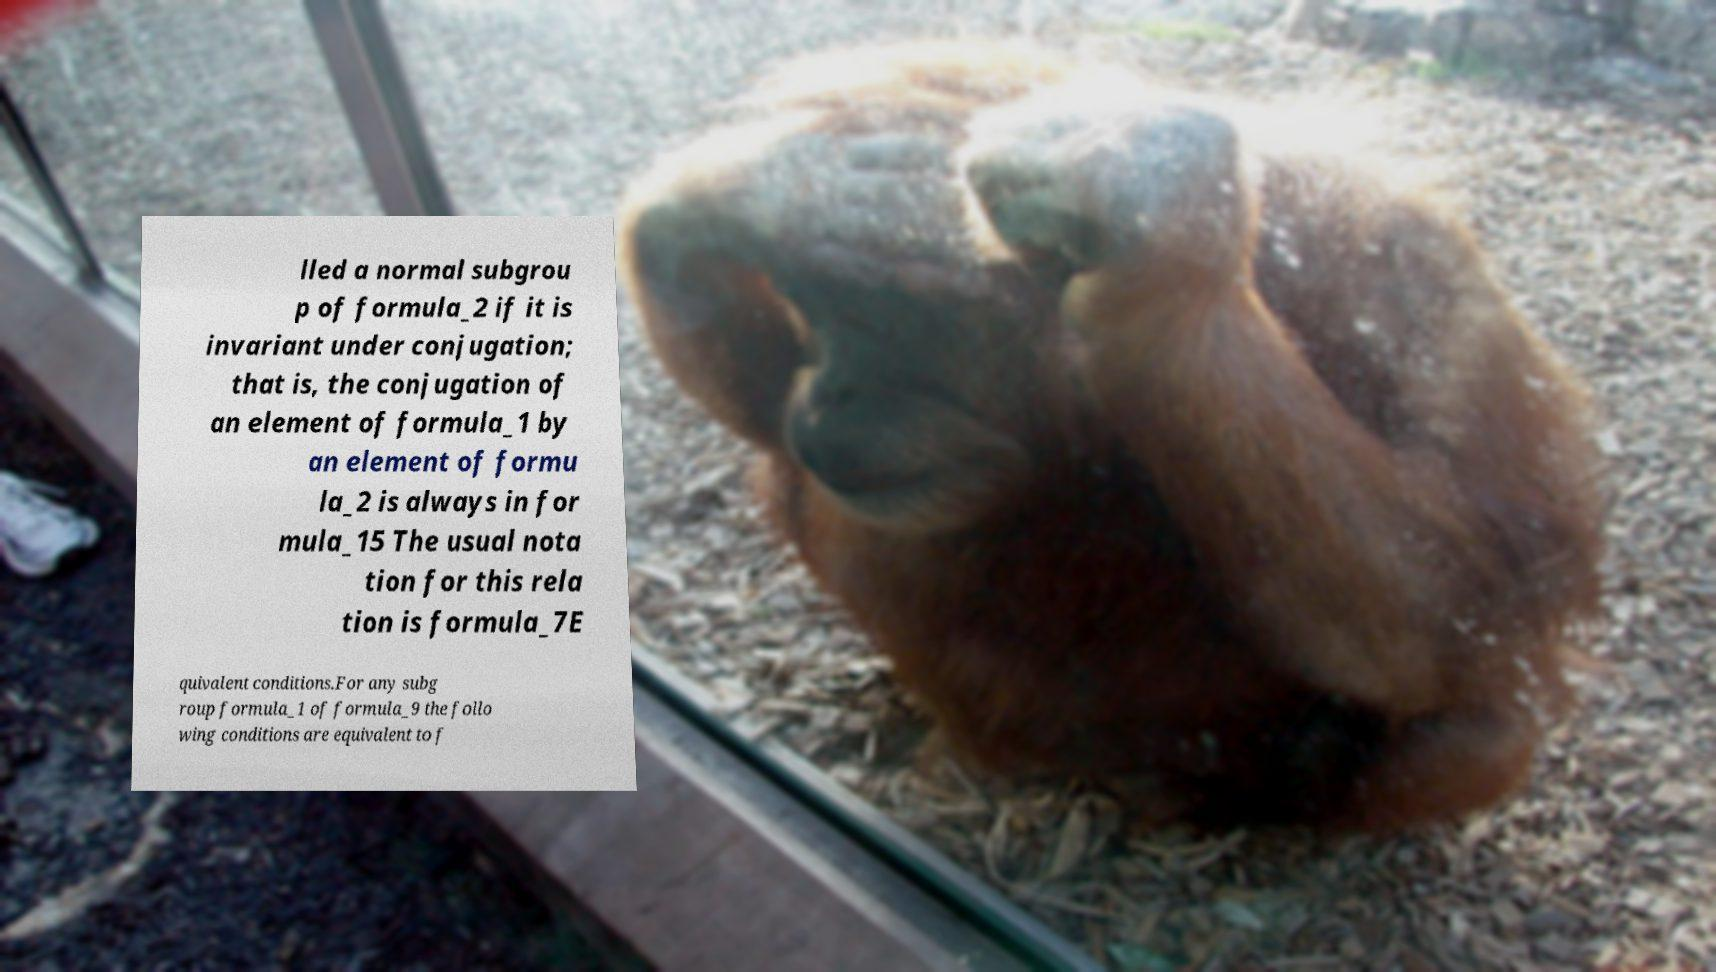Can you accurately transcribe the text from the provided image for me? lled a normal subgrou p of formula_2 if it is invariant under conjugation; that is, the conjugation of an element of formula_1 by an element of formu la_2 is always in for mula_15 The usual nota tion for this rela tion is formula_7E quivalent conditions.For any subg roup formula_1 of formula_9 the follo wing conditions are equivalent to f 